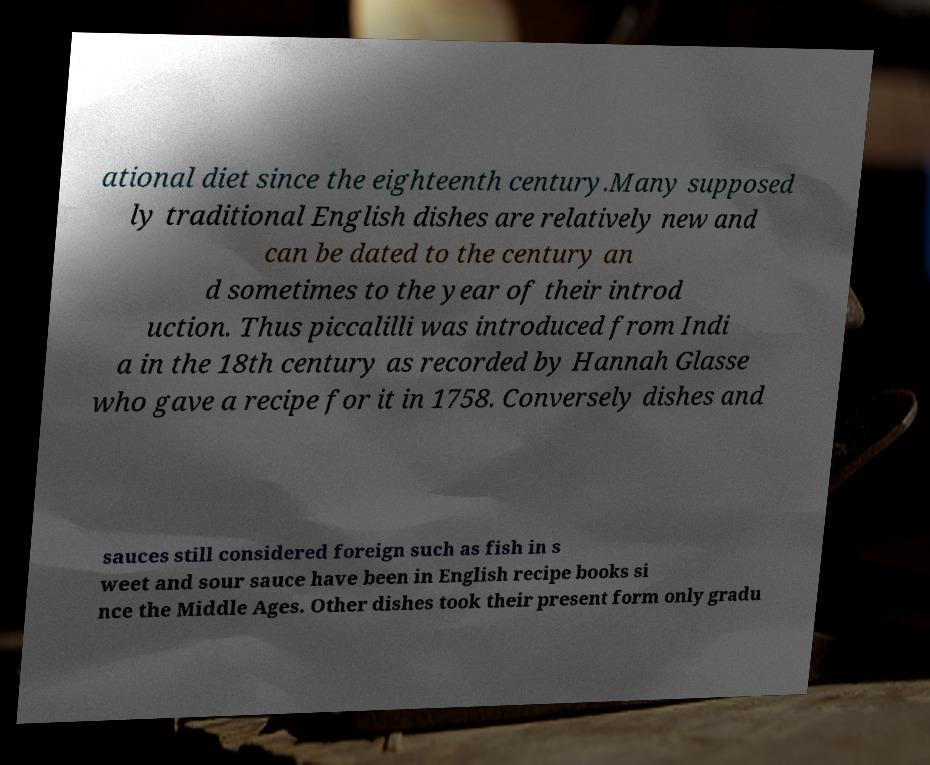Could you extract and type out the text from this image? ational diet since the eighteenth century.Many supposed ly traditional English dishes are relatively new and can be dated to the century an d sometimes to the year of their introd uction. Thus piccalilli was introduced from Indi a in the 18th century as recorded by Hannah Glasse who gave a recipe for it in 1758. Conversely dishes and sauces still considered foreign such as fish in s weet and sour sauce have been in English recipe books si nce the Middle Ages. Other dishes took their present form only gradu 